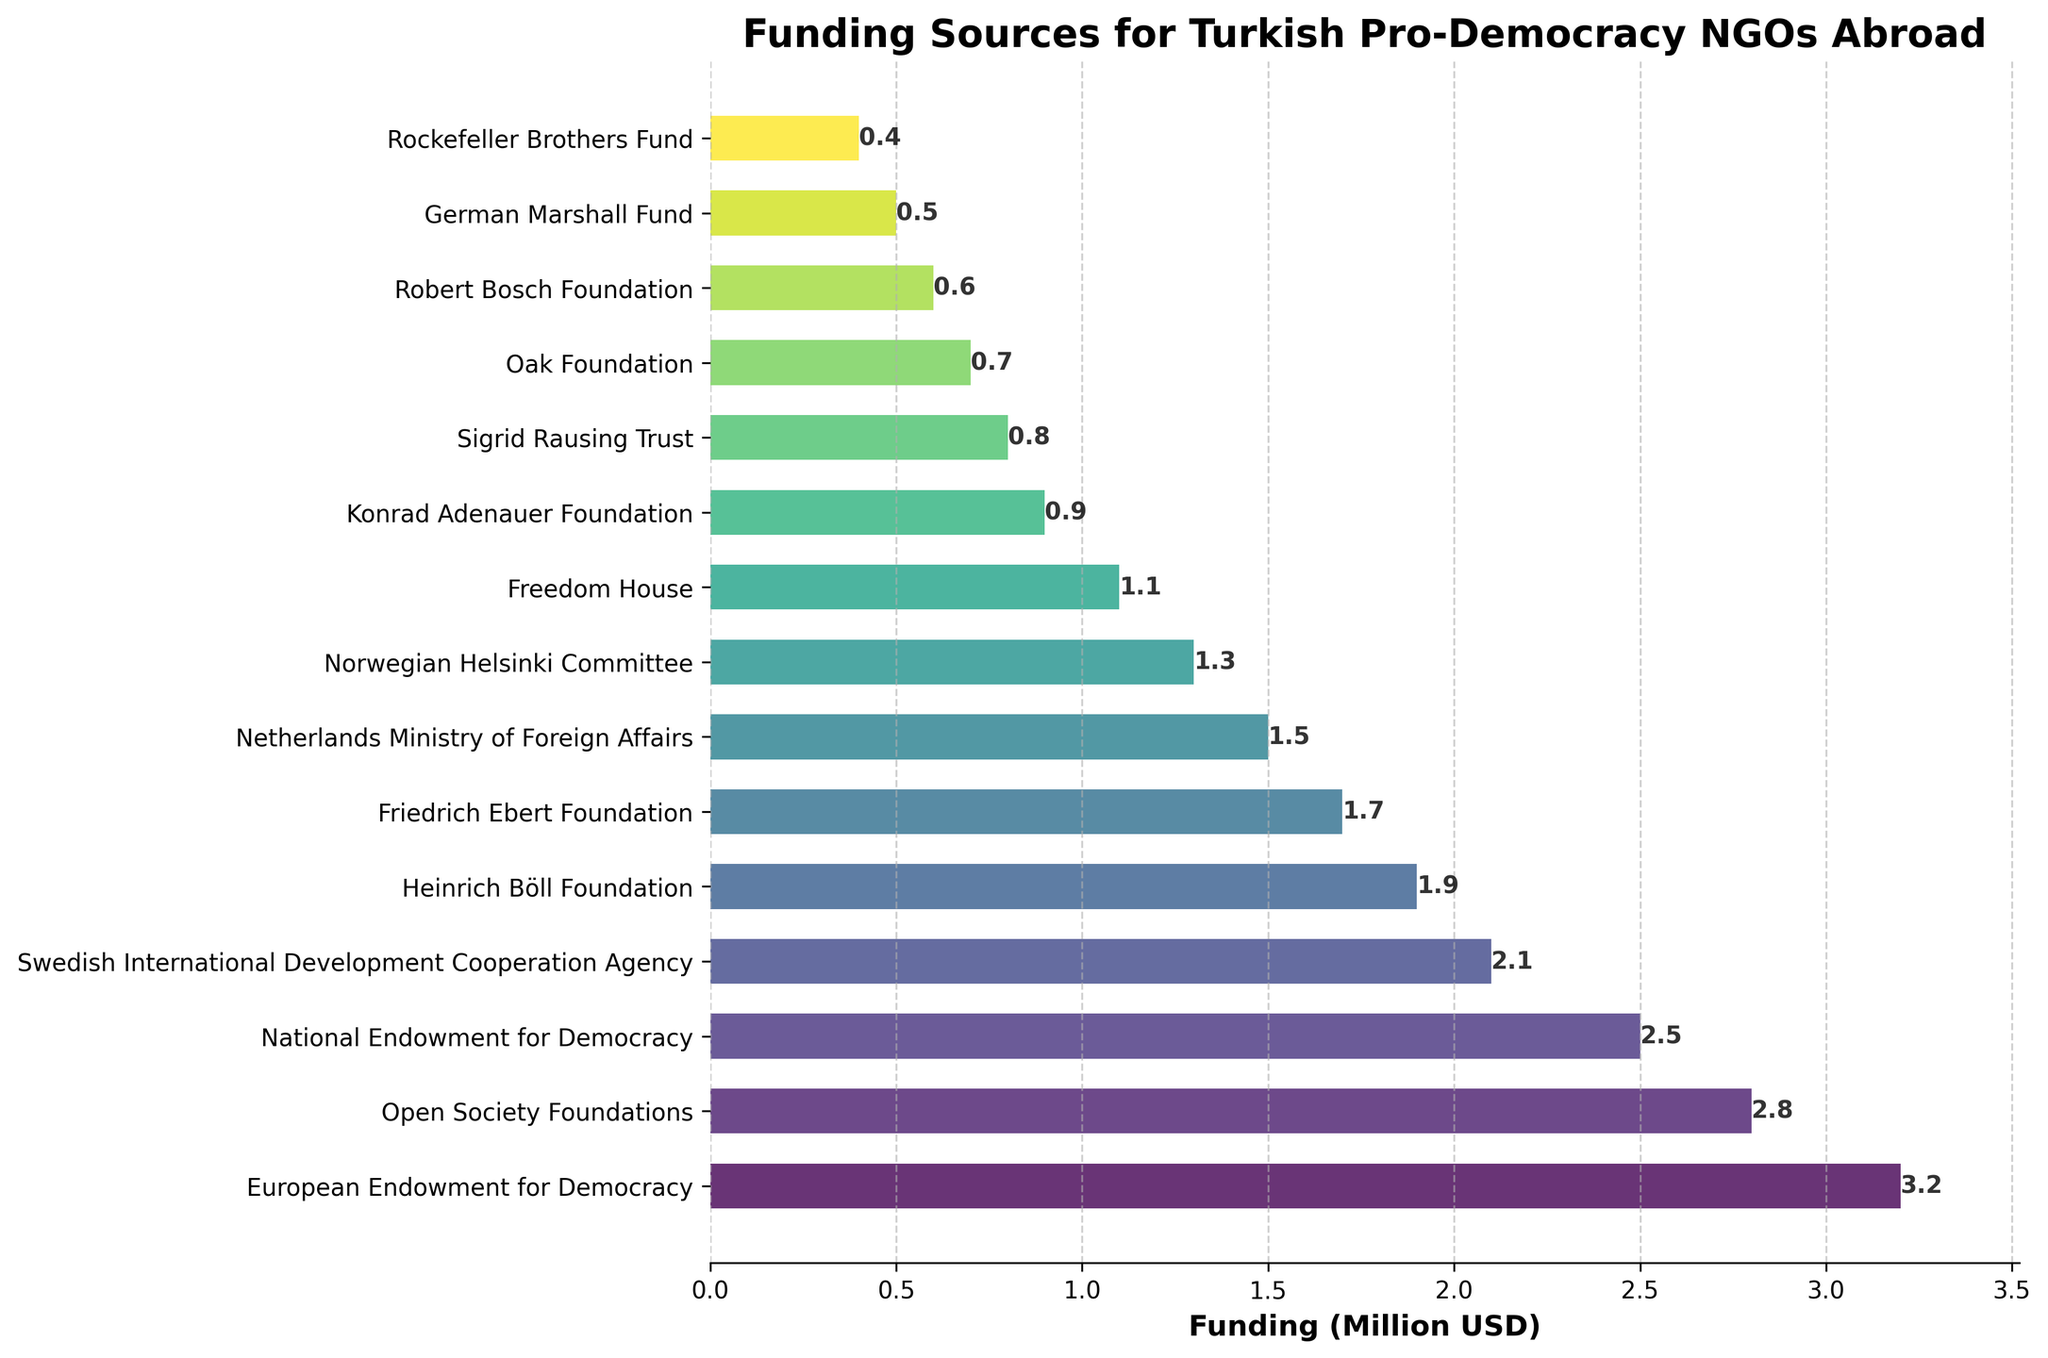Which funding source provides the highest funding to Turkish pro-democracy NGOs abroad? The bar chart shows various funding sources along with their respective funding amounts. The European Endowment for Democracy's bar is the longest, indicating the highest funding amount.
Answer: European Endowment for Democracy What is the total funding provided by the European Endowment for Democracy and the Open Society Foundations? The European Endowment for Democracy provides 3.2 million USD, and the Open Society Foundations provide 2.8 million USD. Adding these amounts gives us 3.2 + 2.8 = 6.0 million USD.
Answer: 6.0 million USD How much more funding does the National Endowment for Democracy provide compared to the Robert Bosch Foundation? The National Endowment for Democracy provides 2.5 million USD, and the Robert Bosch Foundation provides 0.6 million USD. The difference is 2.5 - 0.6 = 1.9 million USD.
Answer: 1.9 million USD Among the top three funding sources, what is the average funding amount provided? The top three funding sources are the European Endowment for Democracy (3.2 million USD), the Open Society Foundations (2.8 million USD), and the National Endowment for Democracy (2.5 million USD). Average is calculated as (3.2 + 2.8 + 2.5) / 3 = 8.5 / 3 = 2.83 million USD.
Answer: 2.83 million USD Which funding source provides the least funding, and how much do they provide? The bar chart shows that the Rockefeller Brothers Fund provides the least funding. Its bar is the shortest, with a length representing 0.4 million USD.
Answer: Rockefeller Brothers Fund, 0.4 million USD Are there any funding sources that provide exactly 0.9 million USD? By examining the lengths of the bars, we find a bar corresponding to 0.9 million USD. The Konrad Adenauer Foundation provides exactly 0.9 million USD.
Answer: Konrad Adenauer Foundation What is the sum of funding provided by all funding sources listed in the chart? Add all the funding amounts given: 3.2 + 2.8 + 2.5 + 2.1 + 1.9 + 1.7 + 1.5 + 1.3 + 1.1 + 0.9 + 0.8 + 0.7 + 0.6 + 0.5 + 0.4 = 21.0 million USD.
Answer: 21.0 million USD Does the Swedish International Development Cooperation Agency provide more or less funding than the Friedrich Ebert Foundation? The Swedish International Development Cooperation Agency provides 2.1 million USD, while the Friedrich Ebert Foundation provides 1.7 million USD. Therefore, the Swedish International Development Cooperation Agency provides more funding.
Answer: More Compare the total funding from European and American sources listed, and state which region provides more overall funding? European sources: European Endowment for Democracy (3.2), Swedish International Development Cooperation Agency (2.1), Heinrich Böll Foundation (1.9), Friedrich Ebert Foundation (1.7), Netherlands Ministry of Foreign Affairs (1.5), Konrad Adenauer Foundation (0.9), Sigrid Rausing Trust (0.8), Robert Bosch Foundation (0.6) - Total: 12.7 million USD. American sources: Open Society Foundations (2.8), National Endowment for Democracy (2.5), Freedom House (1.1), German Marshall Fund (0.5), Rockefeller Brothers Fund (0.4) - Total: 7.3 million USD. European sources provide more funding.
Answer: European sources How many funding sources provide more than 2 million USD? By looking at the bar lengths and amounts, the sources providing more than 2 million USD are the European Endowment for Democracy (3.2), Open Society Foundations (2.8), and National Endowment for Democracy (2.5), totaling three sources.
Answer: 3 